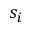Convert formula to latex. <formula><loc_0><loc_0><loc_500><loc_500>s _ { i }</formula> 